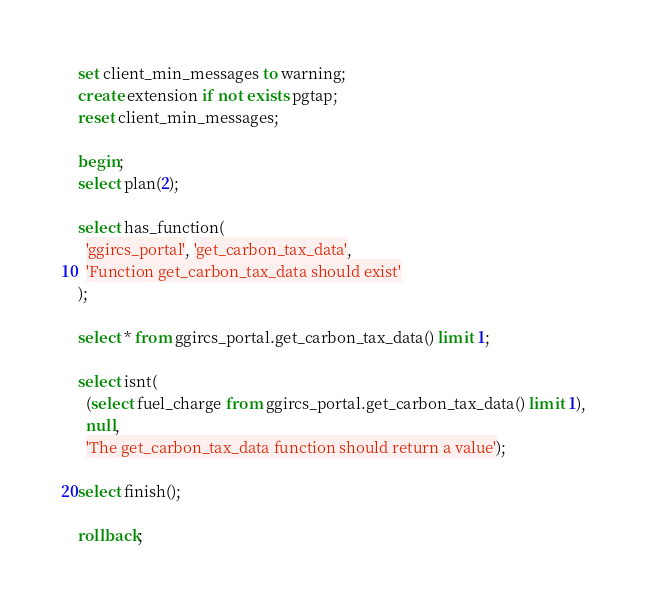<code> <loc_0><loc_0><loc_500><loc_500><_SQL_>set client_min_messages to warning;
create extension if not exists pgtap;
reset client_min_messages;

begin;
select plan(2);

select has_function(
  'ggircs_portal', 'get_carbon_tax_data',
  'Function get_carbon_tax_data should exist'
);

select * from ggircs_portal.get_carbon_tax_data() limit 1;

select isnt(
  (select fuel_charge from ggircs_portal.get_carbon_tax_data() limit 1),
  null,
  'The get_carbon_tax_data function should return a value');

select finish();

rollback;
</code> 